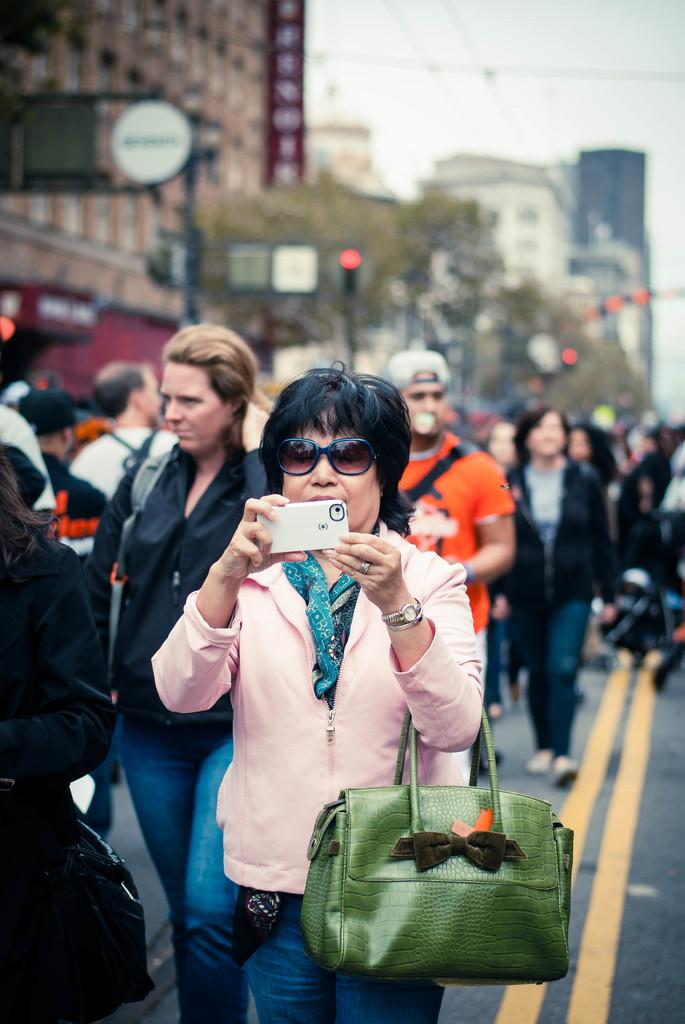What is happening with the group of people in the image? The people are walking on the road in the image. Can you describe the woman in the group? The woman is holding a handbag and a mobile phone. What can be seen in the background of the image? There are buildings and trees visible in the image. What type of ear is visible on the woman in the image? There is no specific ear mentioned or visible in the image; we only know that the woman is holding a mobile phone. Can you tell me how many moms are present in the image? The term "mom" is not mentioned or relevant to the image, as it focuses on a group of people walking on the road. 